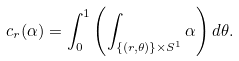Convert formula to latex. <formula><loc_0><loc_0><loc_500><loc_500>c _ { r } ( \alpha ) = \int _ { 0 } ^ { 1 } \left ( \int _ { \{ ( r , \theta ) \} \times S ^ { 1 } } \alpha \right ) d \theta .</formula> 